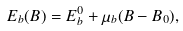Convert formula to latex. <formula><loc_0><loc_0><loc_500><loc_500>E _ { b } ( B ) = E _ { b } ^ { 0 } + \mu _ { b } ( B - B _ { 0 } ) ,</formula> 